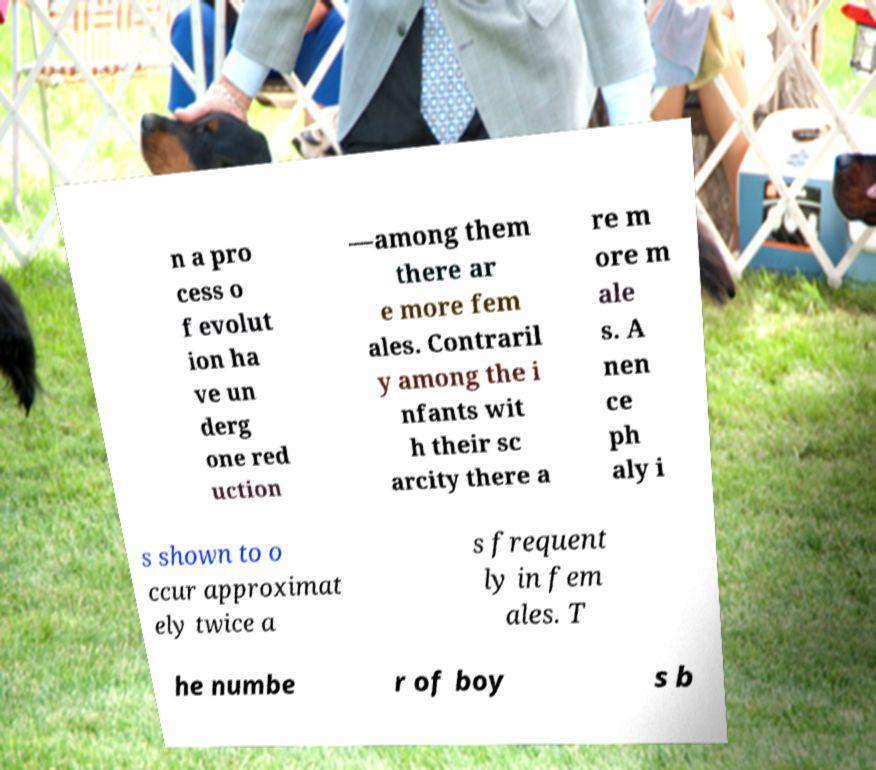Please identify and transcribe the text found in this image. n a pro cess o f evolut ion ha ve un derg one red uction —among them there ar e more fem ales. Contraril y among the i nfants wit h their sc arcity there a re m ore m ale s. A nen ce ph aly i s shown to o ccur approximat ely twice a s frequent ly in fem ales. T he numbe r of boy s b 